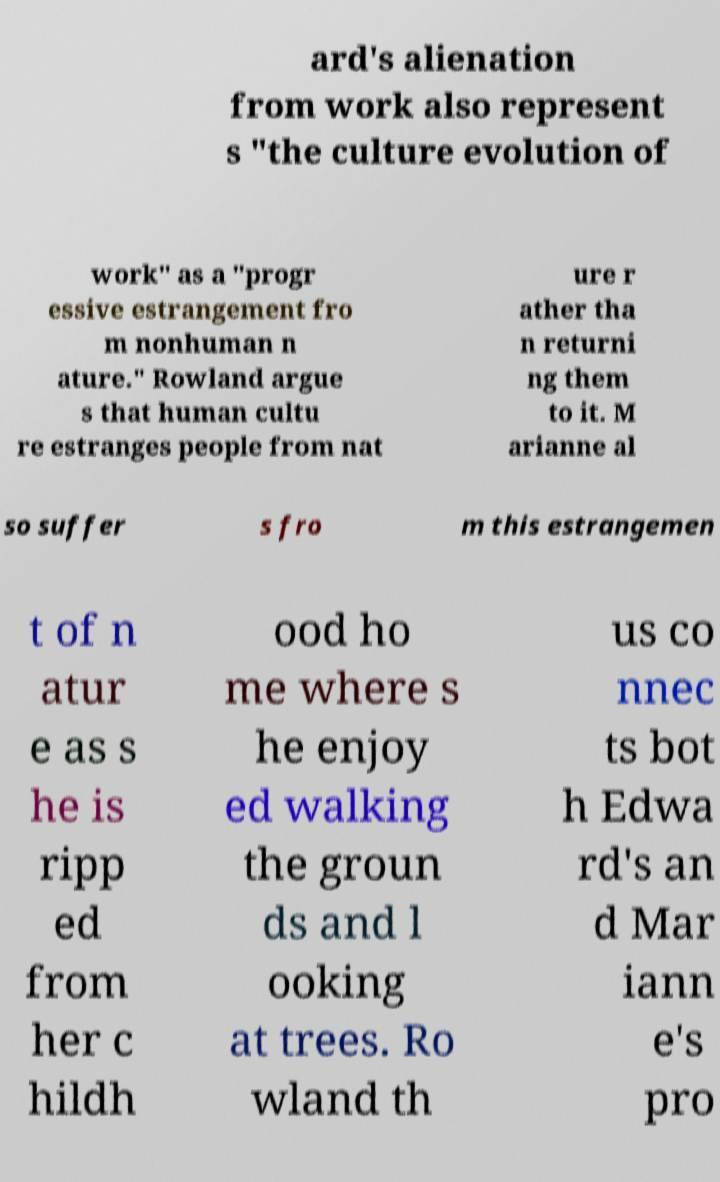Please identify and transcribe the text found in this image. ard's alienation from work also represent s "the culture evolution of work" as a "progr essive estrangement fro m nonhuman n ature." Rowland argue s that human cultu re estranges people from nat ure r ather tha n returni ng them to it. M arianne al so suffer s fro m this estrangemen t of n atur e as s he is ripp ed from her c hildh ood ho me where s he enjoy ed walking the groun ds and l ooking at trees. Ro wland th us co nnec ts bot h Edwa rd's an d Mar iann e's pro 